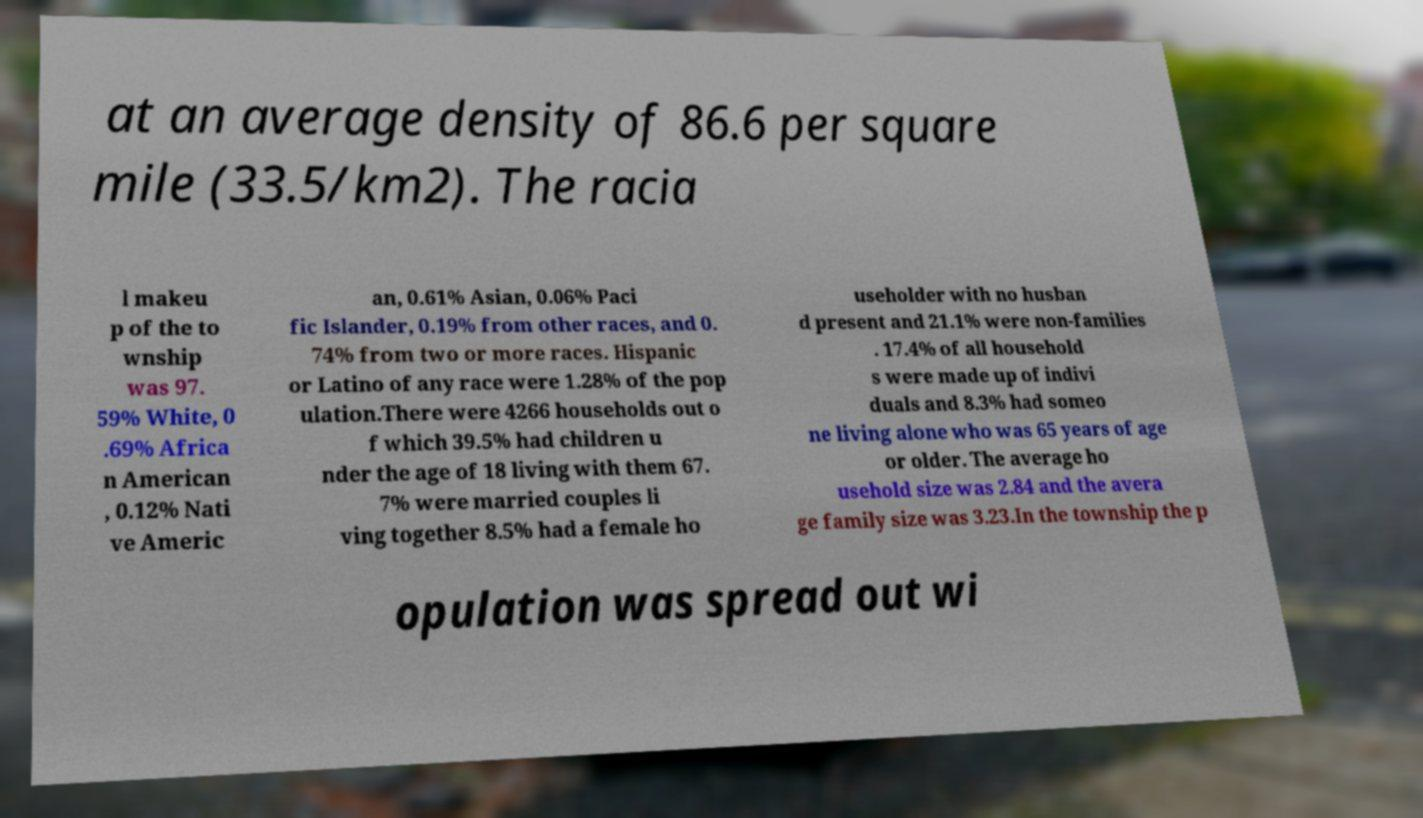There's text embedded in this image that I need extracted. Can you transcribe it verbatim? at an average density of 86.6 per square mile (33.5/km2). The racia l makeu p of the to wnship was 97. 59% White, 0 .69% Africa n American , 0.12% Nati ve Americ an, 0.61% Asian, 0.06% Paci fic Islander, 0.19% from other races, and 0. 74% from two or more races. Hispanic or Latino of any race were 1.28% of the pop ulation.There were 4266 households out o f which 39.5% had children u nder the age of 18 living with them 67. 7% were married couples li ving together 8.5% had a female ho useholder with no husban d present and 21.1% were non-families . 17.4% of all household s were made up of indivi duals and 8.3% had someo ne living alone who was 65 years of age or older. The average ho usehold size was 2.84 and the avera ge family size was 3.23.In the township the p opulation was spread out wi 